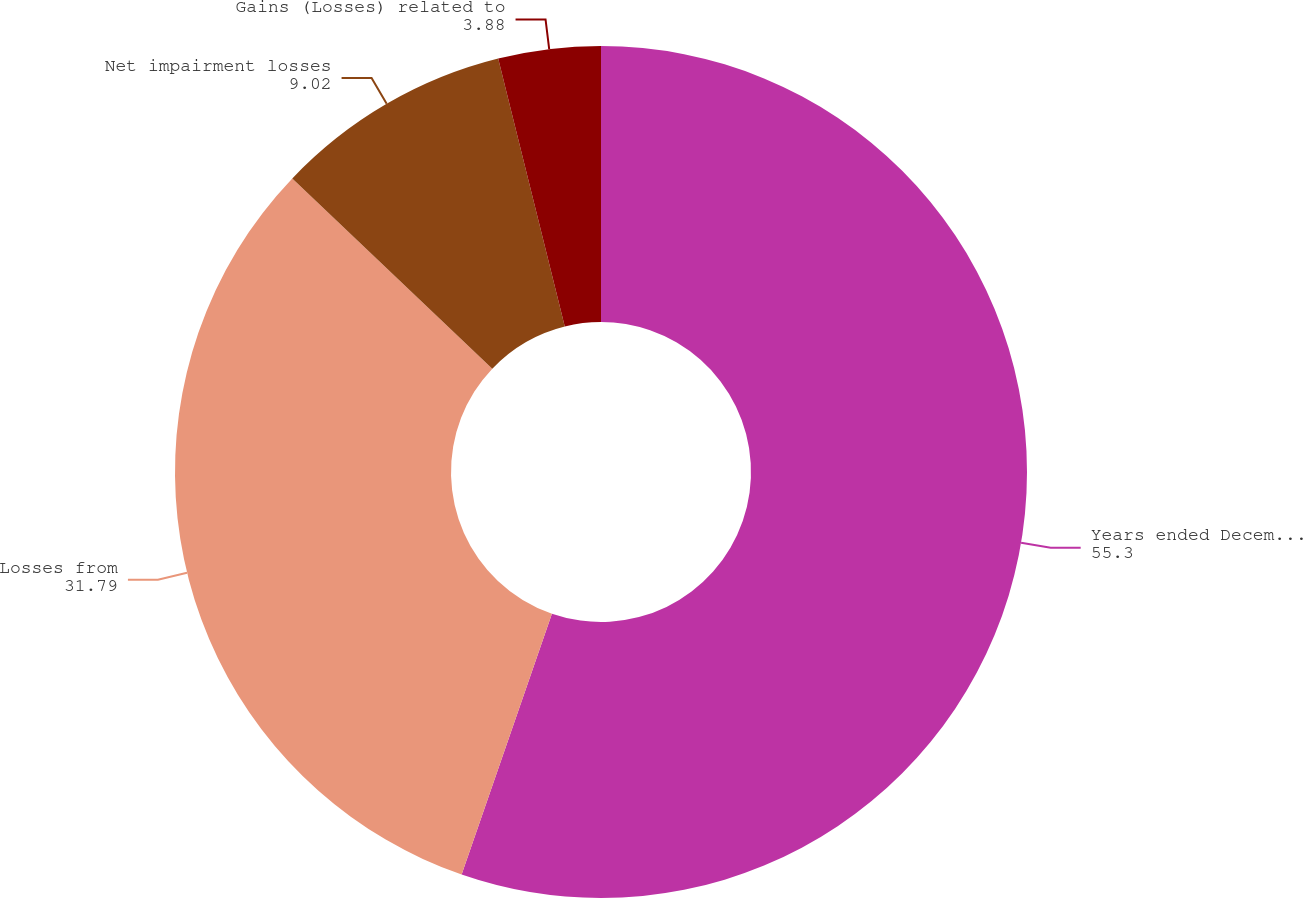Convert chart. <chart><loc_0><loc_0><loc_500><loc_500><pie_chart><fcel>Years ended December 31<fcel>Losses from<fcel>Net impairment losses<fcel>Gains (Losses) related to<nl><fcel>55.3%<fcel>31.79%<fcel>9.02%<fcel>3.88%<nl></chart> 